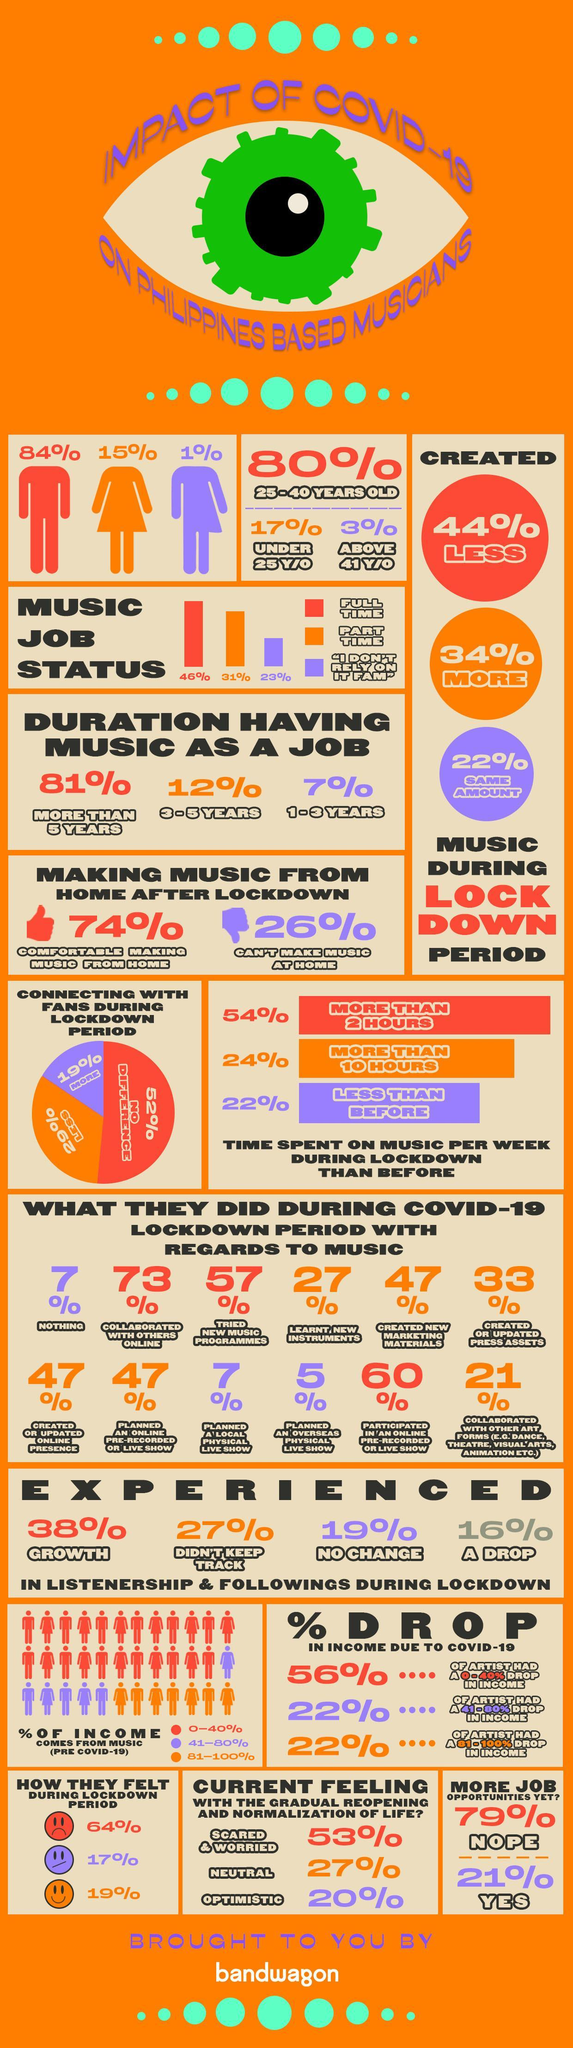What percentage of Philippines based musicians experienced no change in listenership & followings during the lockdown?
Answer the question with a short phrase. 19% What percentage of Philippines based musicians had part time jobs during the lockdown period? 31% What percentage of Philippines based musicians felt no difference in connecting with their fans during the lockdown period? 52% What percentage of Philippines based musicians have been working in the music industry for 3-5 years? 12% What percentage of Philippines based musicians experienced growth in listenership & followings during the lockdown? 38% What percentage of Philippines based musicians created less music during the lockdown period? 44% What percentage of Philippines based musicians experienced a drop in listenership & followings during the lockdown? 16% What percentage of Philippines based musicians created more music during the lockdown period? 34% What percentage of Philippines based musicians had full time jobs during the lockdown period? 46% What percentage of Philippines based musicians have been working in the music industry for more than 5 years? 81% 